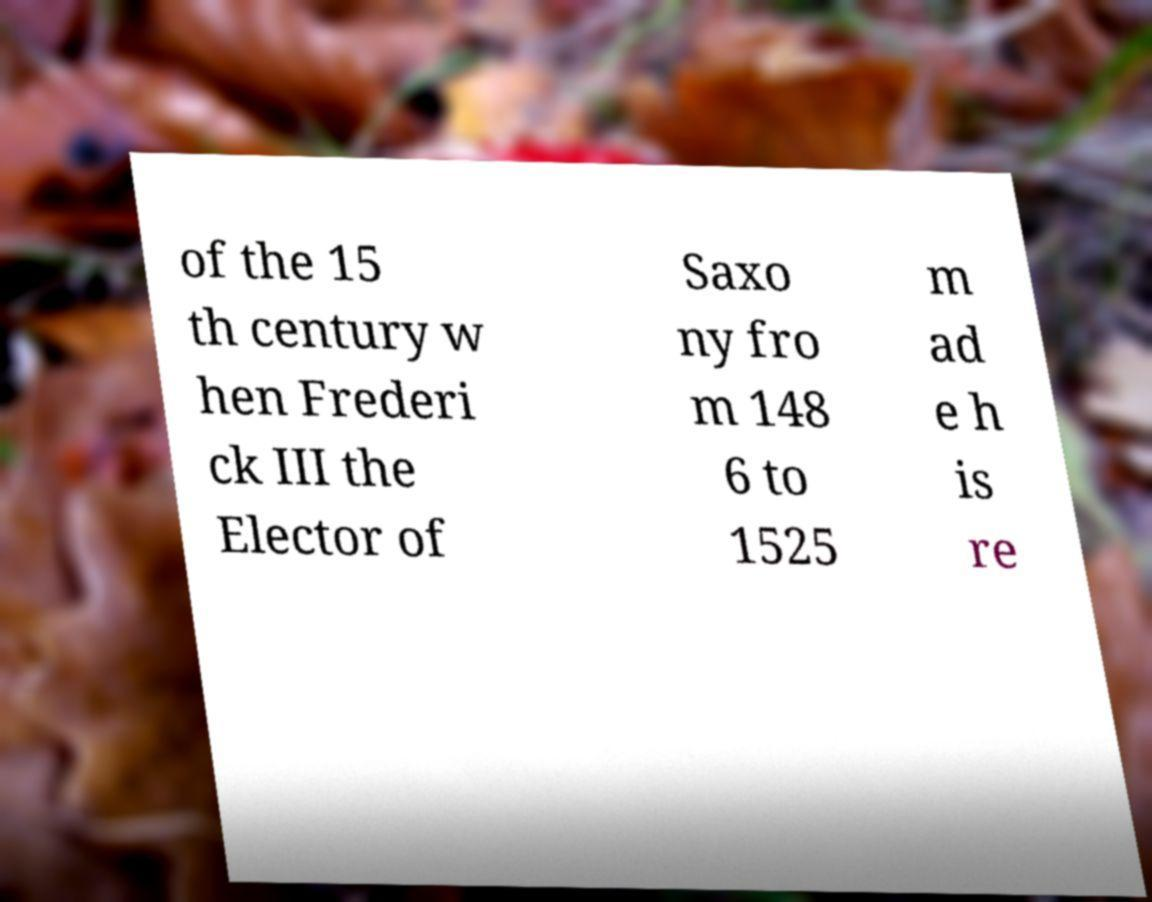Please read and relay the text visible in this image. What does it say? of the 15 th century w hen Frederi ck III the Elector of Saxo ny fro m 148 6 to 1525 m ad e h is re 